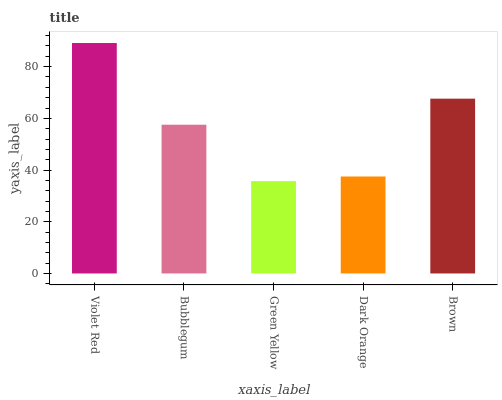Is Green Yellow the minimum?
Answer yes or no. Yes. Is Violet Red the maximum?
Answer yes or no. Yes. Is Bubblegum the minimum?
Answer yes or no. No. Is Bubblegum the maximum?
Answer yes or no. No. Is Violet Red greater than Bubblegum?
Answer yes or no. Yes. Is Bubblegum less than Violet Red?
Answer yes or no. Yes. Is Bubblegum greater than Violet Red?
Answer yes or no. No. Is Violet Red less than Bubblegum?
Answer yes or no. No. Is Bubblegum the high median?
Answer yes or no. Yes. Is Bubblegum the low median?
Answer yes or no. Yes. Is Dark Orange the high median?
Answer yes or no. No. Is Dark Orange the low median?
Answer yes or no. No. 